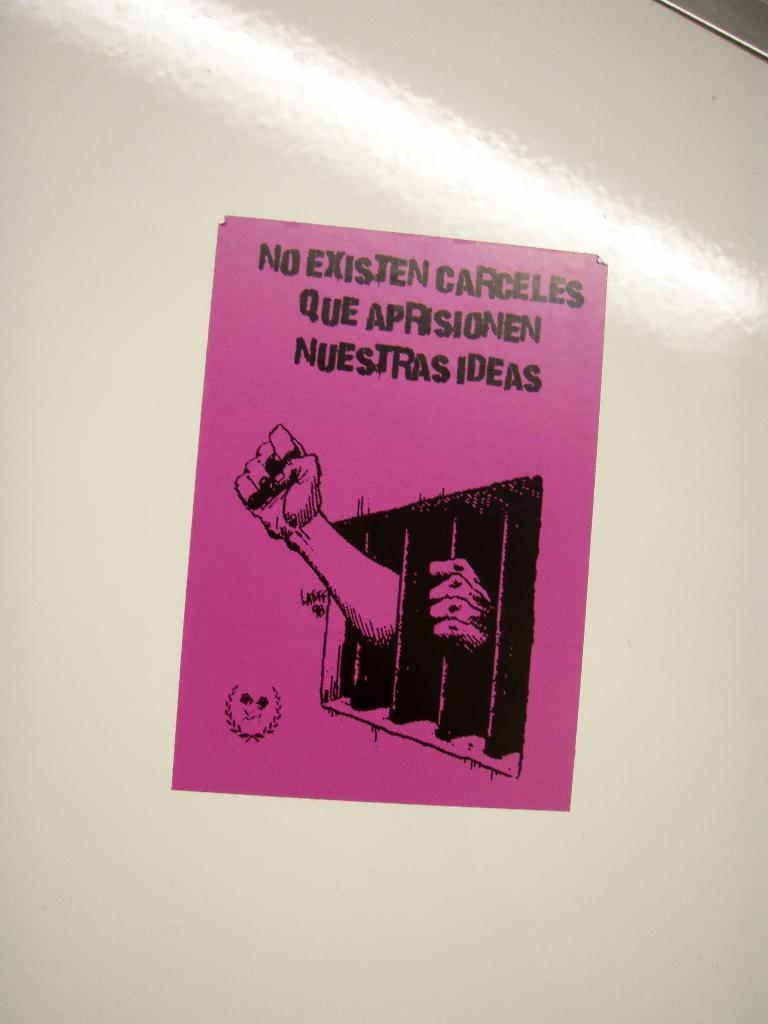<image>
Relay a brief, clear account of the picture shown. A pink resistance poster contains the phrase No Existen Carceles Que Aprisionen Nuestras Ideas. 